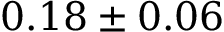<formula> <loc_0><loc_0><loc_500><loc_500>0 . 1 8 \pm 0 . 0 6</formula> 